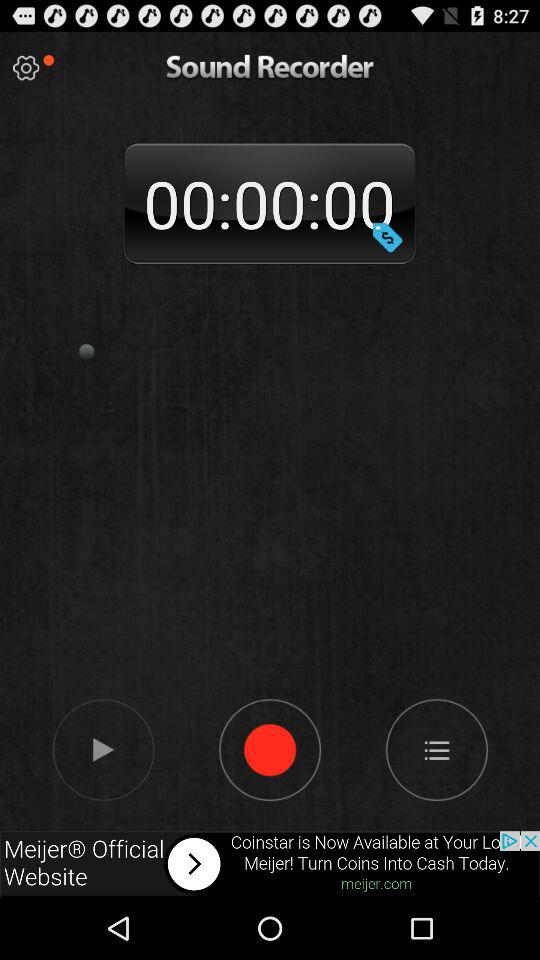What is the name of the application? The name of the application is "Sound Recorder". 